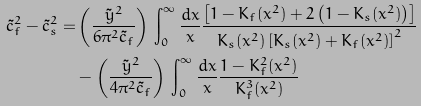<formula> <loc_0><loc_0><loc_500><loc_500>\tilde { c } _ { f } ^ { 2 } - \tilde { c } _ { s } ^ { 2 } = & \left ( \frac { \tilde { y } ^ { 2 } } { 6 \pi ^ { 2 } \tilde { c } _ { f } } \right ) \, \int _ { 0 } ^ { \infty } \frac { d x } { x } \frac { \left [ 1 - K _ { f } ( x ^ { 2 } ) + 2 \left ( 1 - K _ { s } ( x ^ { 2 } ) \right ) \right ] } { K _ { s } ( x ^ { 2 } ) \left [ K _ { s } ( x ^ { 2 } ) + K _ { f } ( x ^ { 2 } ) \right ] ^ { 2 } } \\ & - \left ( \frac { \tilde { y } ^ { 2 } } { 4 \pi ^ { 2 } \tilde { c } _ { f } } \right ) \, \int _ { 0 } ^ { \infty } \frac { d x } { x } \frac { 1 - K _ { f } ^ { 2 } ( x ^ { 2 } ) } { K _ { f } ^ { 3 } ( x ^ { 2 } ) }</formula> 